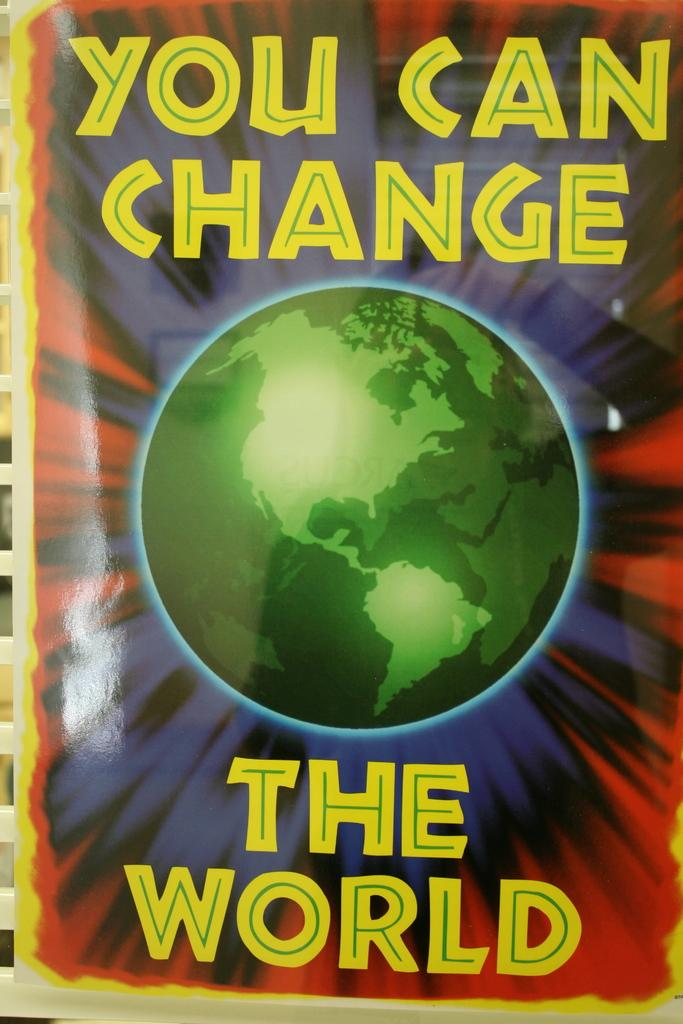What is the main subject of the poster in the image? The poster contains an image of a globe. Are there any other elements on the poster besides the image? Yes, there is text written on the poster. How many men are coughing on the street in the image? There are no men or streets present in the image; it only features a poster with a globe and text. 